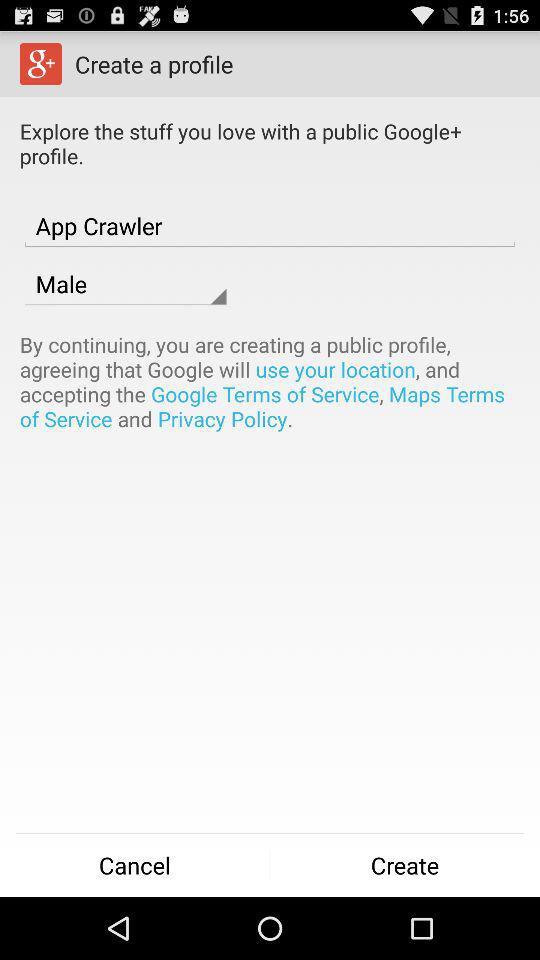What is the user name? The user name is App Crawler. 